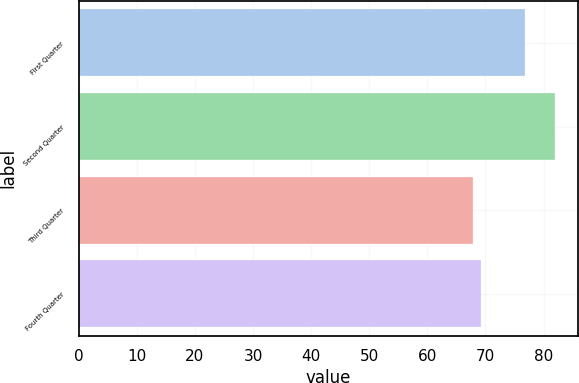<chart> <loc_0><loc_0><loc_500><loc_500><bar_chart><fcel>First Quarter<fcel>Second Quarter<fcel>Third Quarter<fcel>Fourth Quarter<nl><fcel>76.75<fcel>81.92<fcel>67.9<fcel>69.3<nl></chart> 